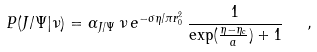<formula> <loc_0><loc_0><loc_500><loc_500>P ( J / \Psi | \nu ) = \alpha _ { J / \Psi } \, \nu \, e ^ { - \sigma \eta / \pi r _ { 0 } ^ { 2 } } \, { \frac { 1 } { \exp ( { \frac { \eta - \eta _ { c } } { a } } ) + 1 } } \ \ ,</formula> 